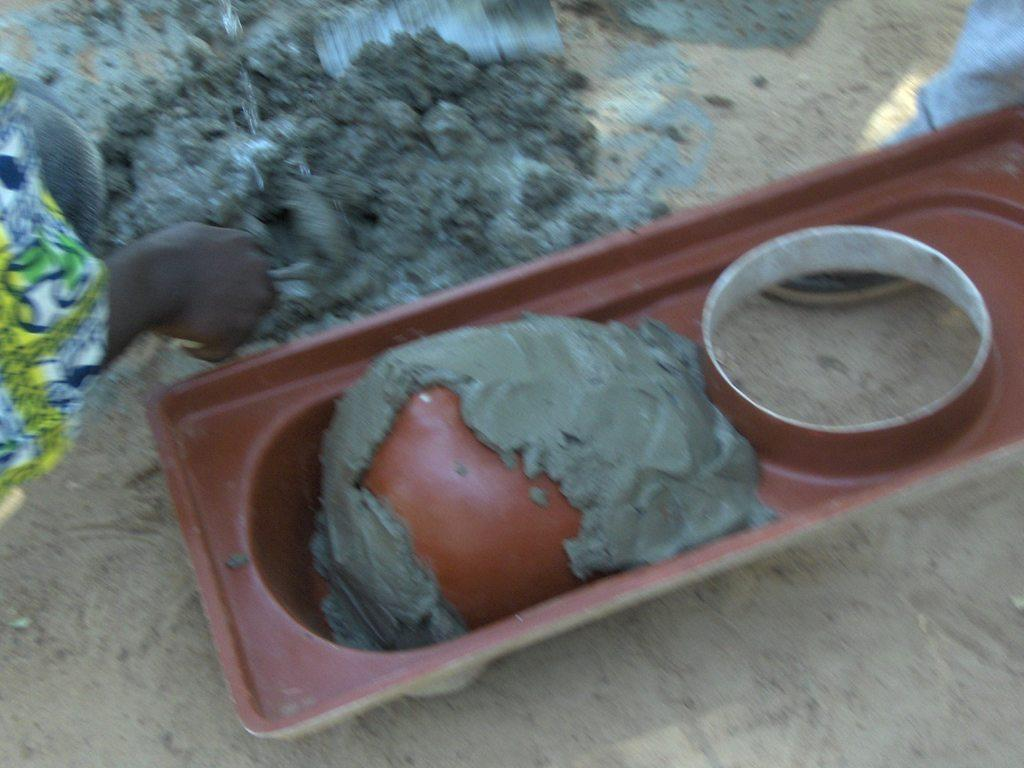What is inside the box that is visible in the image? There is a box with concrete in the image. What can be seen on the left side of the image? There is a hand of a person on the left side of the image. What is on the ground in the image? There is concrete on the ground in the image. What type of farm animals can be seen grazing in the image? There is no farm or animals present in the image; it features a box with concrete, a hand, and concrete on the ground. How many rings are visible on the person's hand in the image? There is no person's hand with rings visible in the image; only a hand is present. 